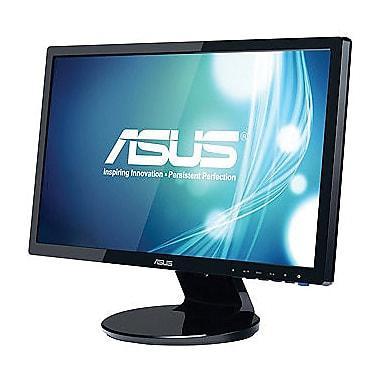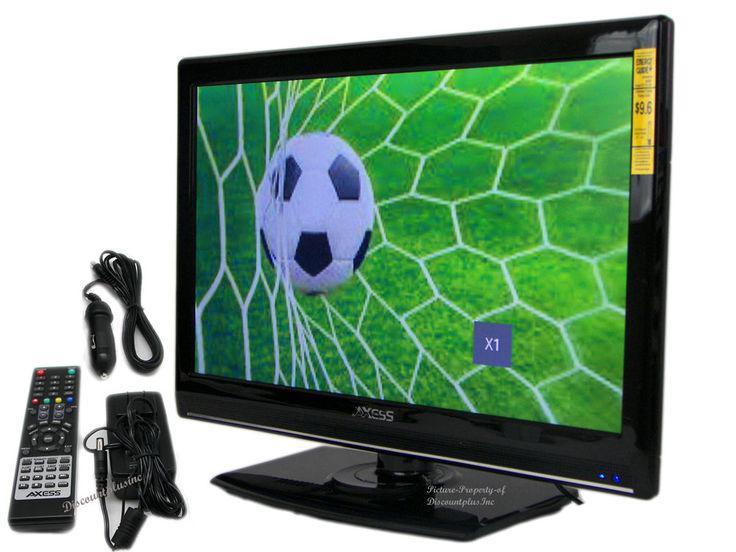The first image is the image on the left, the second image is the image on the right. Considering the images on both sides, is "The TV on the right is viewed head-on, and the TV on the left is displayed at an angle." valid? Answer yes or no. No. 